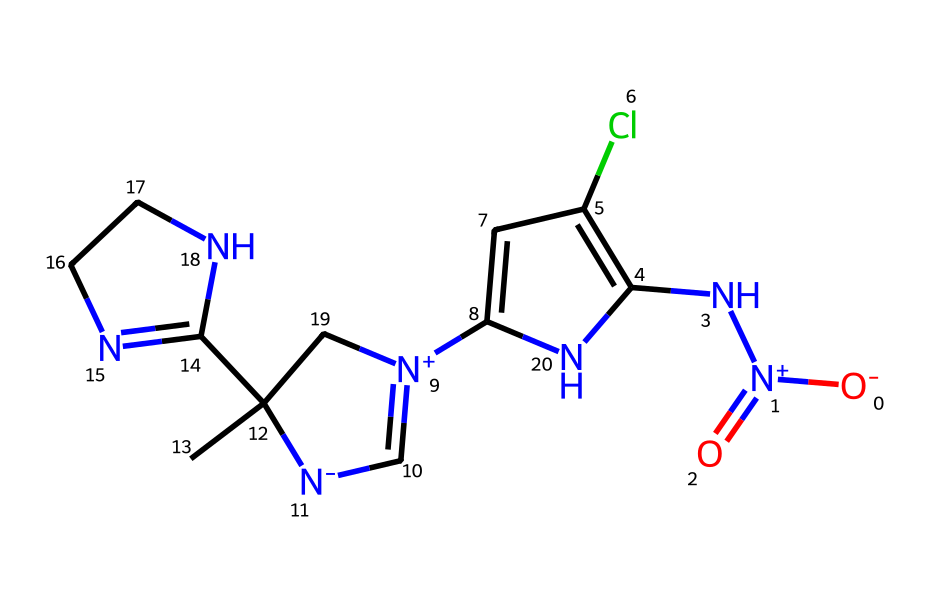What is the molecular formula of imidacloprid? To determine the molecular formula, we count the number of each type of atom in the SMILES representation. Parsing it reveals C, H, Cl, N, and O atoms, leading to the formula C12H15ClN4O2.
Answer: C12H15ClN4O2 How many nitrogen atoms are present in imidacloprid? Inspecting the structure shows that there are four nitrogen atoms in the chemical structure, as identified by the symbols 'N' present in the SMILES notation.
Answer: 4 What type of compound is imidacloprid classified as? By examining the structure and functional groups in the SMILES, it becomes clear that it exhibits characteristics of a nitro-guanidine, which is specific to this chemical type.
Answer: nitro-guanidine What is the total number of rings in the structure of imidacloprid? By analyzing the chemical structure, we find one cyclic component forming a six-membered ring, thus concluding that there is one ring present in the structure.
Answer: 1 How many oxygen atoms are present in imidacloprid? Upon reviewing the SMILES, there are two oxygen atoms indicated by the 'O' symbols present, confirming the quantity of oxygen in the molecular structure.
Answer: 2 What is the substitution pattern around the benzene-like ring in imidacloprid? After examining the SMILES and the structure, we note there are substitutions at multiple positions on the benzene-like ring, specifically with a chlorine atom and a nitrogen group.
Answer: multi-substituted Is the imidacloprid molecule polar or nonpolar? Analyzing the functional groups, particularly the presence of nitrogen and oxygen atoms, which are electronegative, indicates that imidacloprid is a polar molecule due to its charge distribution.
Answer: polar 